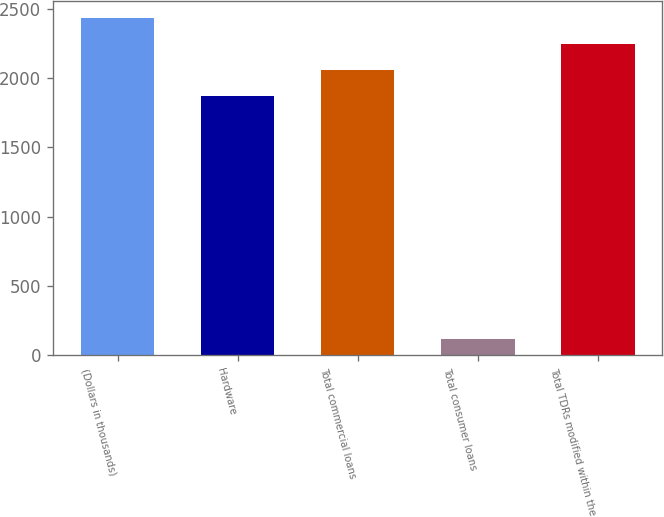<chart> <loc_0><loc_0><loc_500><loc_500><bar_chart><fcel>(Dollars in thousands)<fcel>Hardware<fcel>Total commercial loans<fcel>Total consumer loans<fcel>Total TDRs modified within the<nl><fcel>2435.6<fcel>1868<fcel>2057.2<fcel>120<fcel>2246.4<nl></chart> 